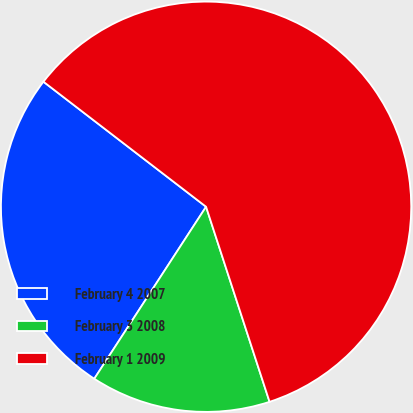Convert chart. <chart><loc_0><loc_0><loc_500><loc_500><pie_chart><fcel>February 4 2007<fcel>February 3 2008<fcel>February 1 2009<nl><fcel>26.26%<fcel>14.18%<fcel>59.56%<nl></chart> 